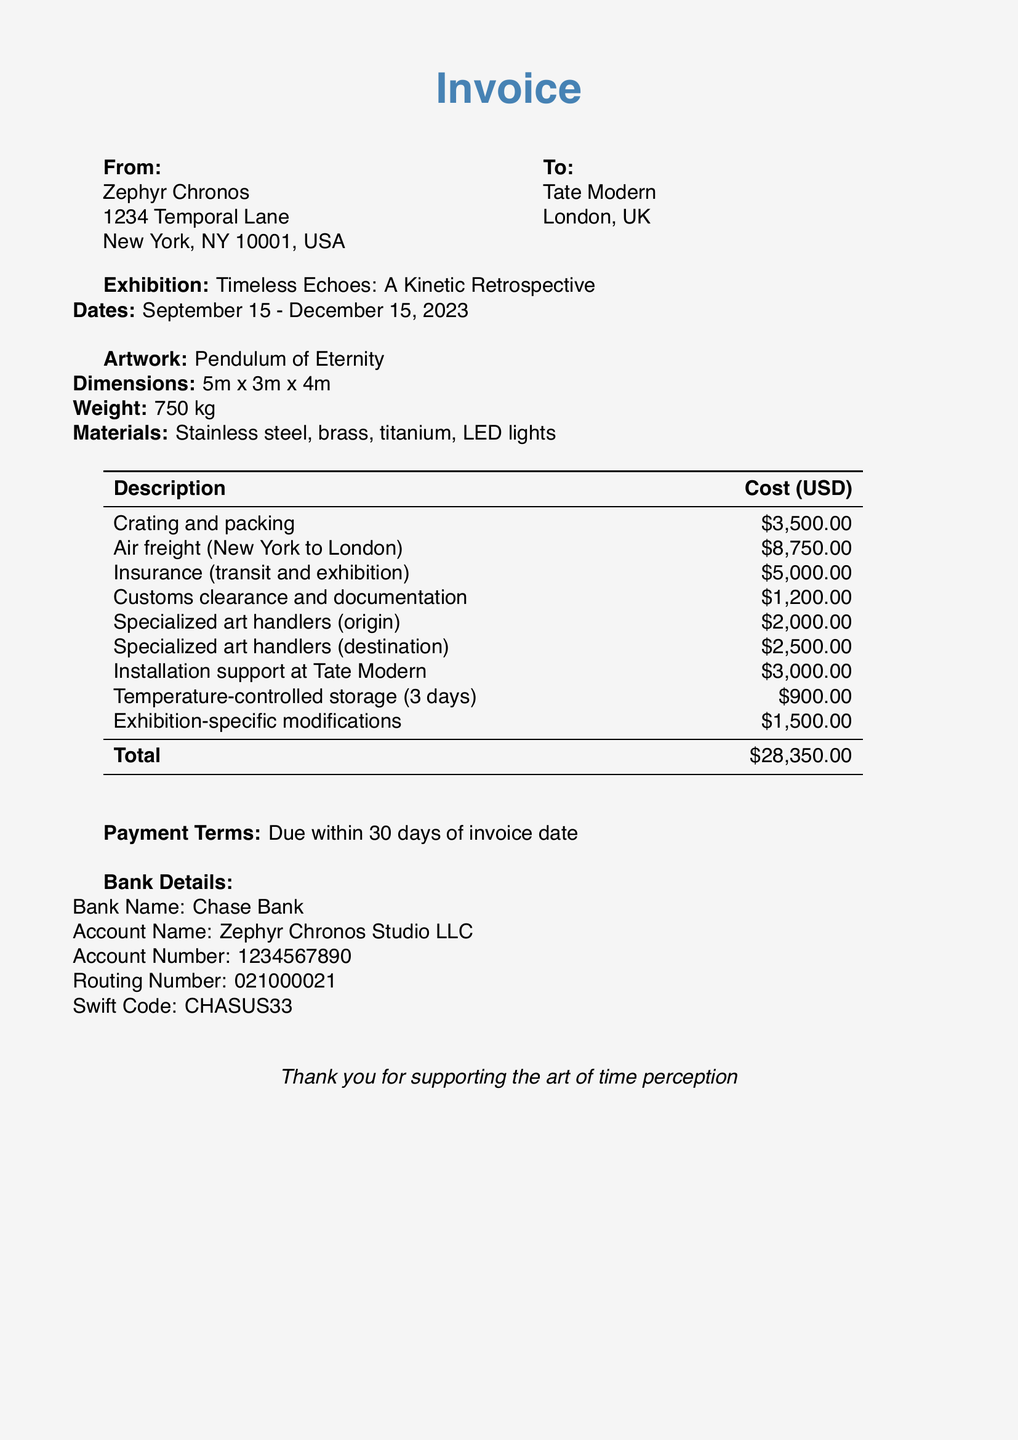What is the total cost of shipping? The total cost is found in the table showing all the described charges, which sums up to $28,350.00.
Answer: $28,350.00 Who is the sender of the invoice? The sender's name is provided at the beginning of the document, listed as Zephyr Chronos.
Answer: Zephyr Chronos What is the weight of the artwork? The weight is explicitly stated in the artwork details section, which shows the weight to be 750 kg.
Answer: 750 kg How much is charged for insurance? The cost for insurance is listed in the table, detailing it as $5,000.00.
Answer: $5,000.00 What is the name of the artwork? The artwork's title is mentioned under the artwork section as "Pendulum of Eternity."
Answer: Pendulum of Eternity When is the exhibition scheduled to end? The end date for the exhibition is given in the exhibition details, stating December 15, 2023.
Answer: December 15, 2023 How much will the specialized art handlers at the destination cost? The cost for specialized art handlers at the destination is indicated in the table as $2,500.00.
Answer: $2,500.00 What is the payment term stated in the document? The payment terms can be found at the bottom of the document, specifying "Due within 30 days of invoice date."
Answer: Due within 30 days of invoice date What is the shipping method used for transport? The shipping method is described as "Air freight (New York to London)" in the cost breakdown table.
Answer: Air freight 